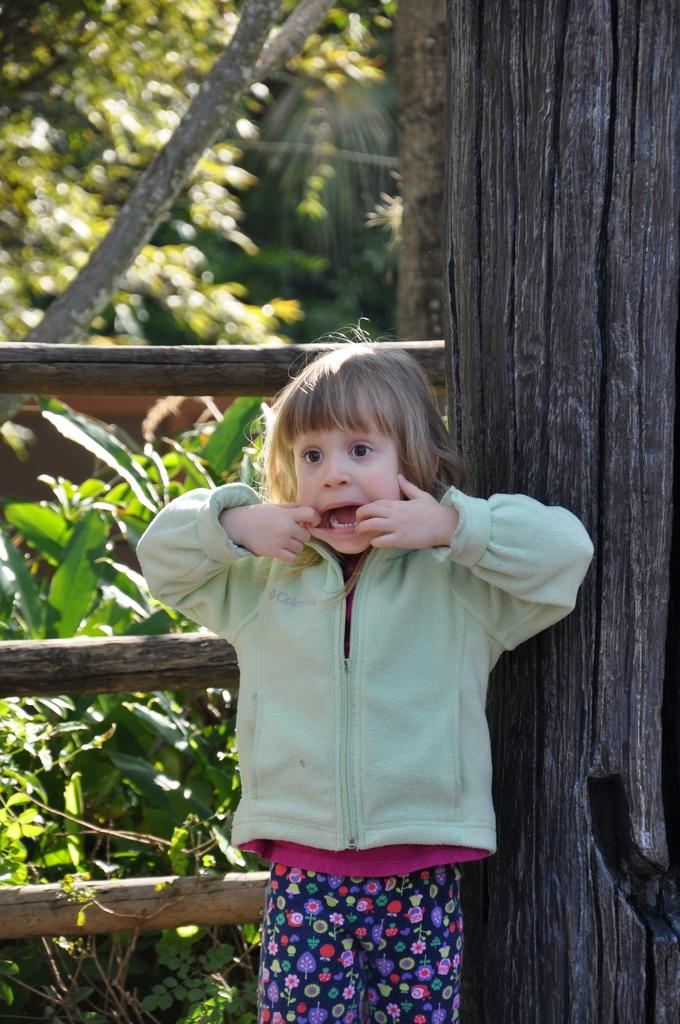What is the main subject of the image? The main subject of the image is a kid. What objects can be seen in the image besides the kid? There are wooden poles, plants, and trees in the image. What is the kid's interest in the wind and friction in the image? There is no indication in the image that the kid has any interest in wind or friction, as these concepts are not depicted or implied in the image. 